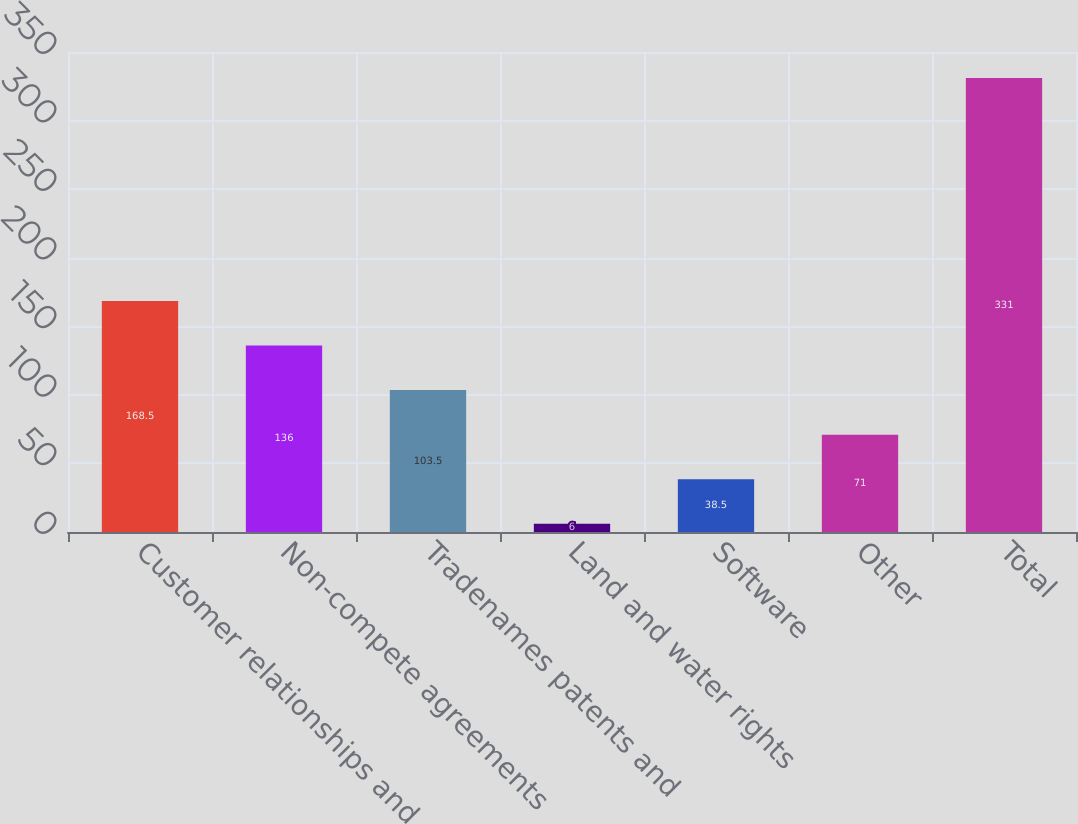<chart> <loc_0><loc_0><loc_500><loc_500><bar_chart><fcel>Customer relationships and<fcel>Non-compete agreements<fcel>Tradenames patents and<fcel>Land and water rights<fcel>Software<fcel>Other<fcel>Total<nl><fcel>168.5<fcel>136<fcel>103.5<fcel>6<fcel>38.5<fcel>71<fcel>331<nl></chart> 